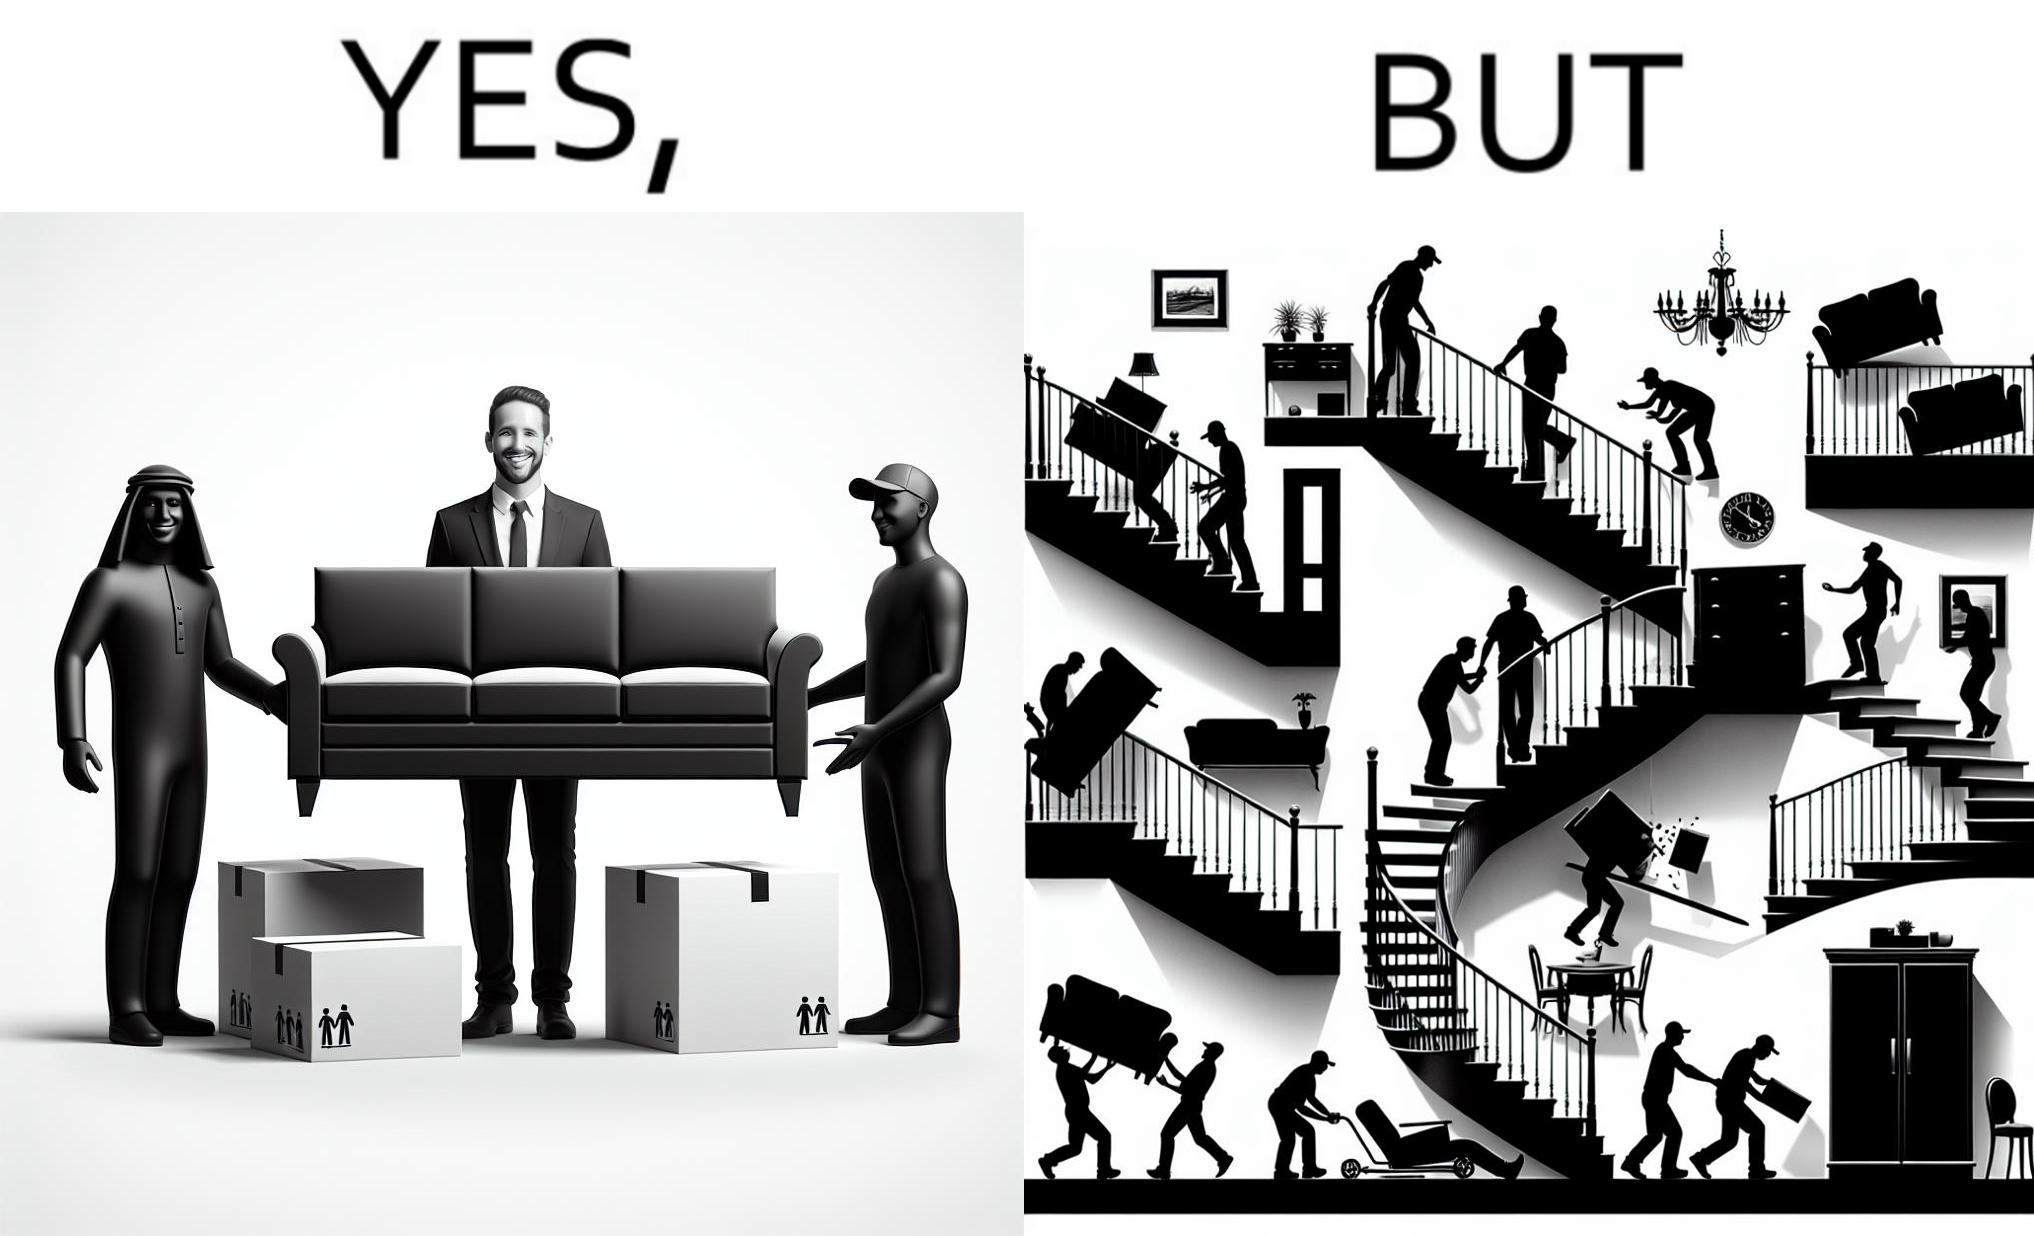Is this a satirical image? Yes, this image is satirical. 